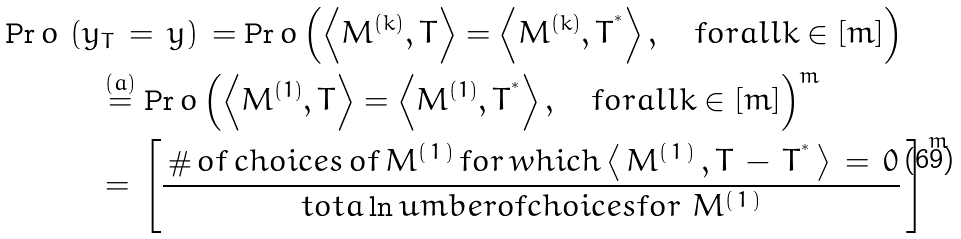<formula> <loc_0><loc_0><loc_500><loc_500>\Pr o \, & \left ( y _ { T } \, = \, y \right ) \, = \Pr o \left ( \left \langle M ^ { ( k ) } , T \right \rangle = \left \langle M ^ { ( k ) } , T ^ { ^ { * } } \right \rangle , \quad f o r a l l k \in [ m ] \right ) \\ & \quad \stackrel { ( a ) } { = } { \Pr o \left ( \left \langle M ^ { ( 1 ) } , T \right \rangle = \left \langle M ^ { ( 1 ) } , T ^ { ^ { * } } \right \rangle , \quad f o r a l l k \in [ m ] \right ) } ^ { m } \\ & \quad = \, \left [ \frac { \, \# \, o f \, c h o i c e s \, o f \, M ^ { ( \, 1 \, ) } \, f o r \, w h i c h \left \langle \, M ^ { ( \, 1 \, ) } \, , T \, - \, T ^ { ^ { * } } \, \right \rangle \, = \, 0 } { t o t a \ln u m b e r o f c h o i c e s f o r \ M ^ { ( \, 1 \, ) } } \, \right ] ^ { \, m }</formula> 